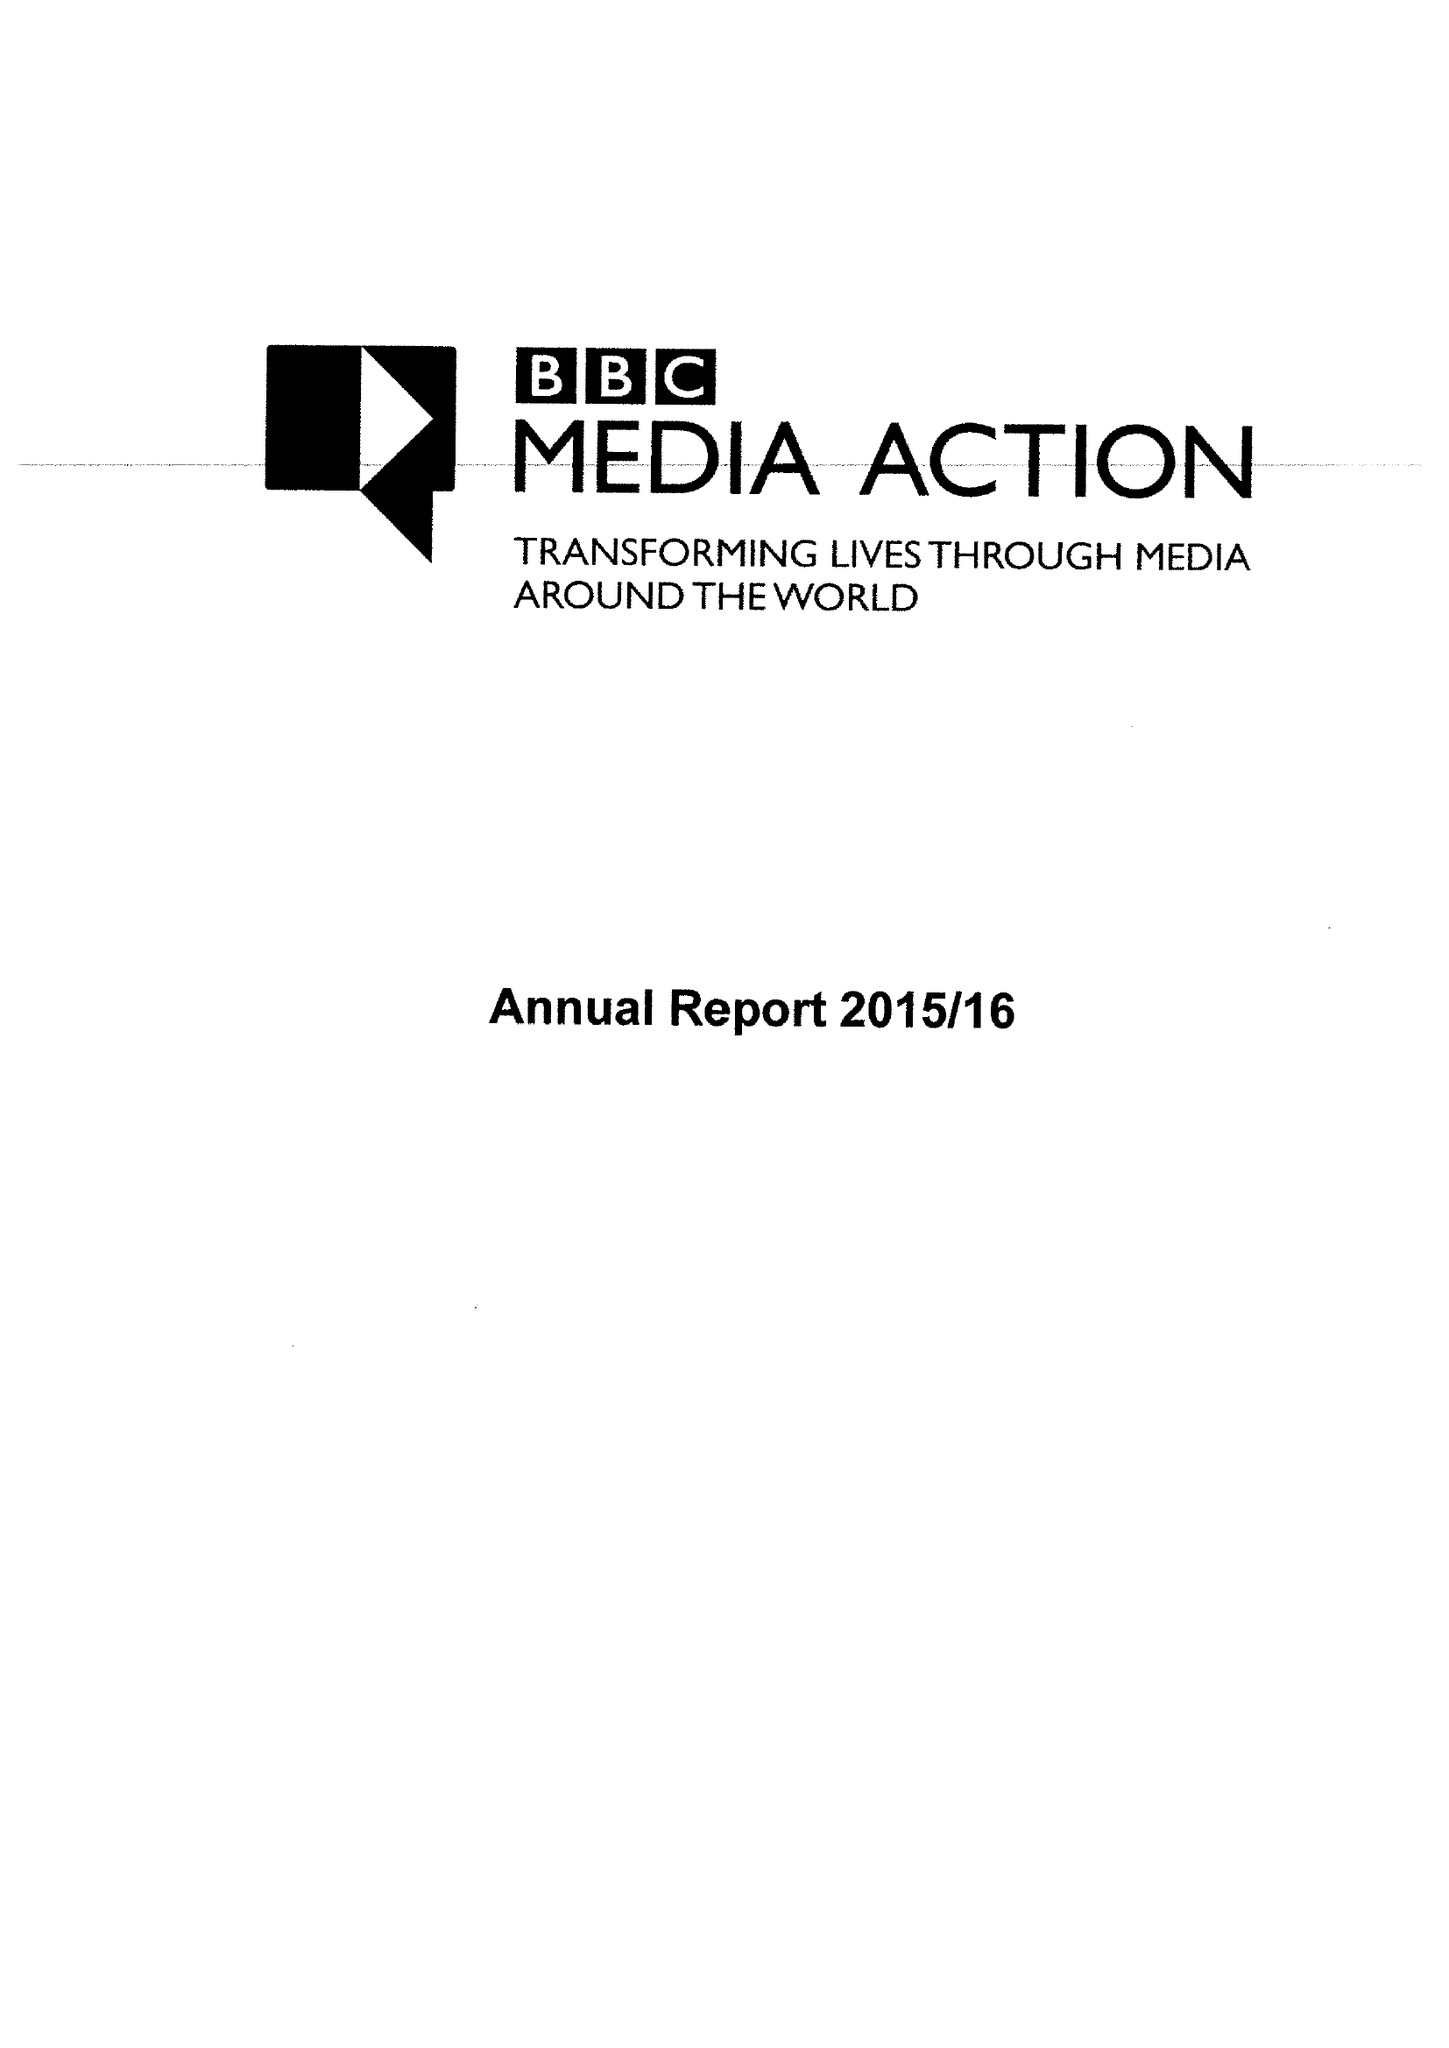What is the value for the report_date?
Answer the question using a single word or phrase. 2016-03-31 